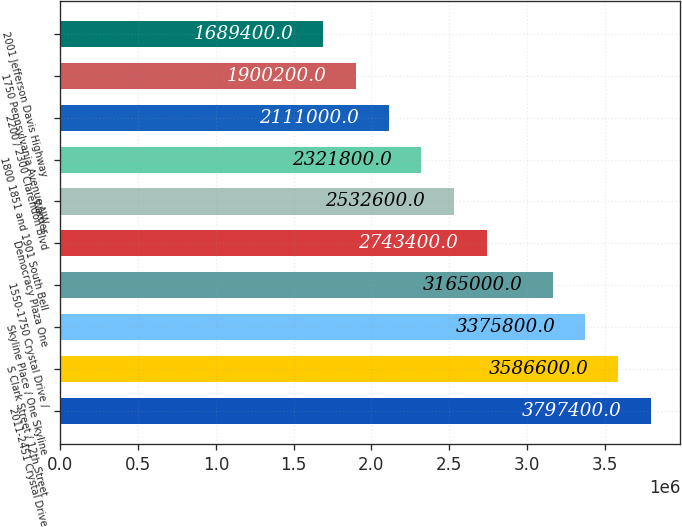<chart> <loc_0><loc_0><loc_500><loc_500><bar_chart><fcel>2011-2451 Crystal Drive<fcel>S Clark Street / 12th Street<fcel>Skyline Place / One Skyline<fcel>1550-1750 Crystal Drive /<fcel>Democracy Plaza One<fcel>Warner<fcel>1800 1851 and 1901 South Bell<fcel>2200 / 2300 Clarendon Blvd<fcel>1750 Pennsylvania Avenue NW<fcel>2001 Jefferson Davis Highway<nl><fcel>3.7974e+06<fcel>3.5866e+06<fcel>3.3758e+06<fcel>3.165e+06<fcel>2.7434e+06<fcel>2.5326e+06<fcel>2.3218e+06<fcel>2.111e+06<fcel>1.9002e+06<fcel>1.6894e+06<nl></chart> 